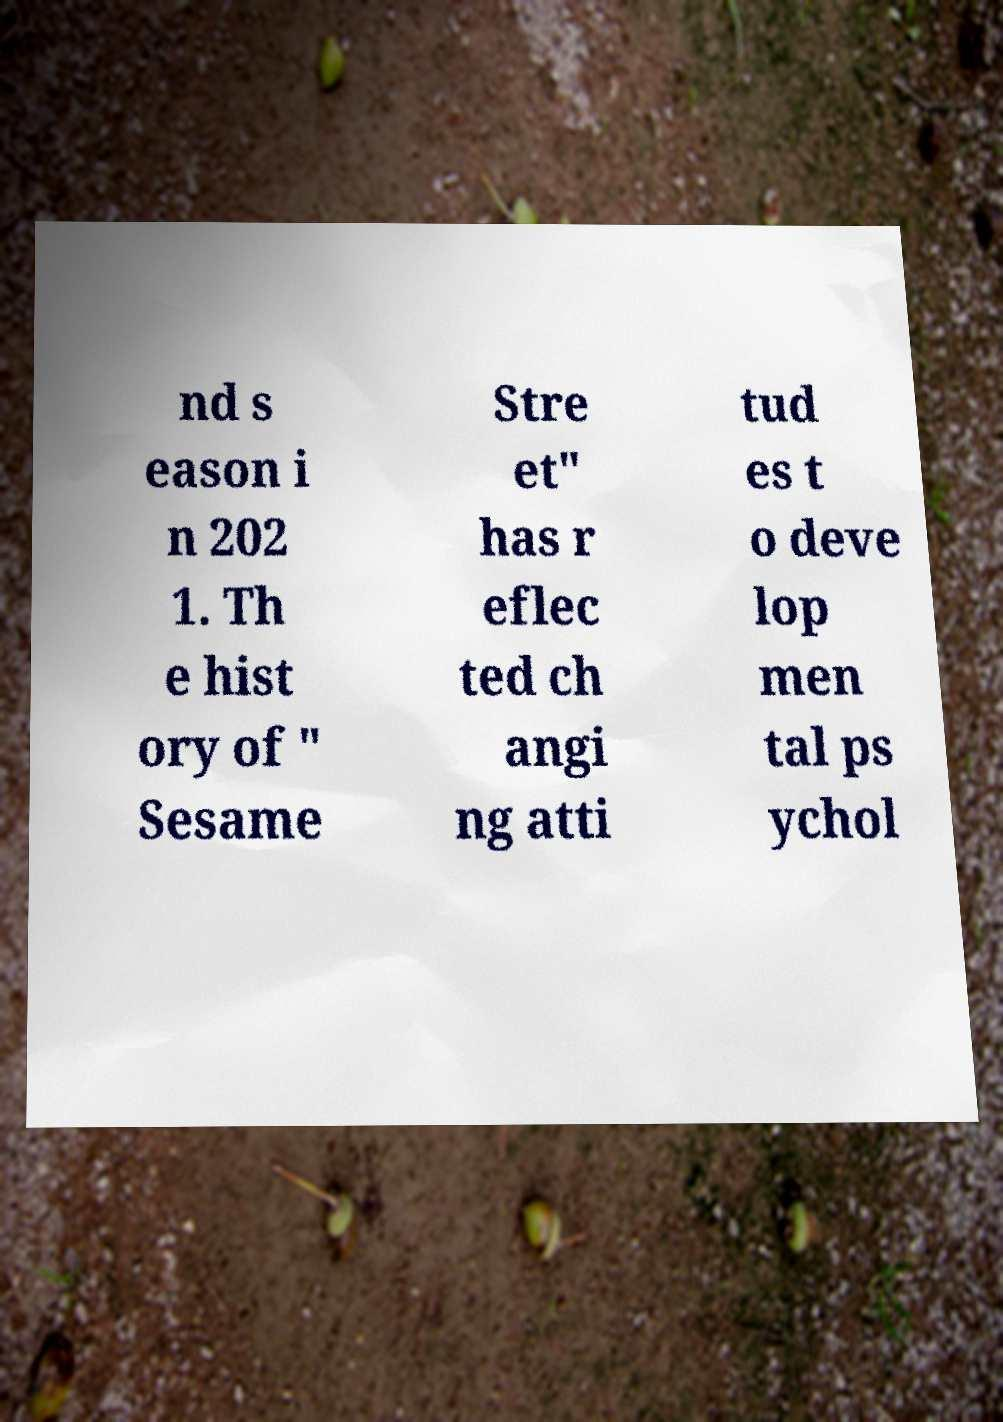What messages or text are displayed in this image? I need them in a readable, typed format. nd s eason i n 202 1. Th e hist ory of " Sesame Stre et" has r eflec ted ch angi ng atti tud es t o deve lop men tal ps ychol 